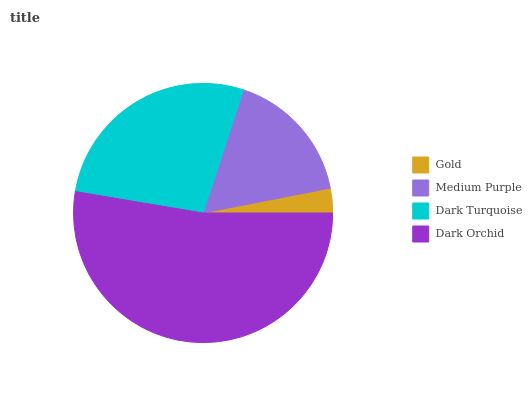Is Gold the minimum?
Answer yes or no. Yes. Is Dark Orchid the maximum?
Answer yes or no. Yes. Is Medium Purple the minimum?
Answer yes or no. No. Is Medium Purple the maximum?
Answer yes or no. No. Is Medium Purple greater than Gold?
Answer yes or no. Yes. Is Gold less than Medium Purple?
Answer yes or no. Yes. Is Gold greater than Medium Purple?
Answer yes or no. No. Is Medium Purple less than Gold?
Answer yes or no. No. Is Dark Turquoise the high median?
Answer yes or no. Yes. Is Medium Purple the low median?
Answer yes or no. Yes. Is Gold the high median?
Answer yes or no. No. Is Dark Turquoise the low median?
Answer yes or no. No. 